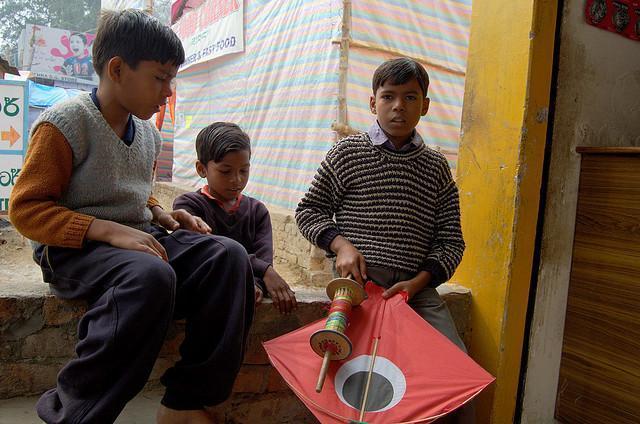How many people are there?
Give a very brief answer. 3. 